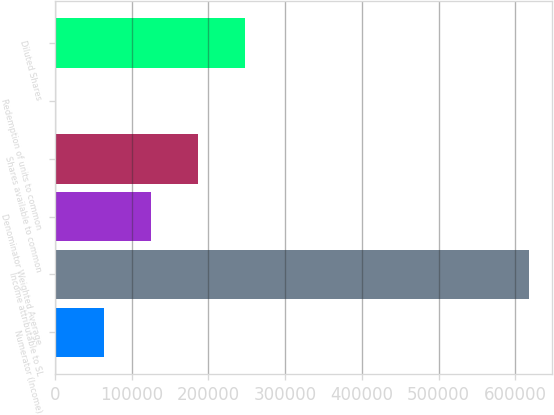Convert chart. <chart><loc_0><loc_0><loc_500><loc_500><bar_chart><fcel>Numerator (Income)<fcel>Income attributable to SL<fcel>Denominator Weighted Average<fcel>Shares available to common<fcel>Redemption of units to common<fcel>Diluted Shares<nl><fcel>63509.7<fcel>617232<fcel>125034<fcel>186559<fcel>1985<fcel>248084<nl></chart> 